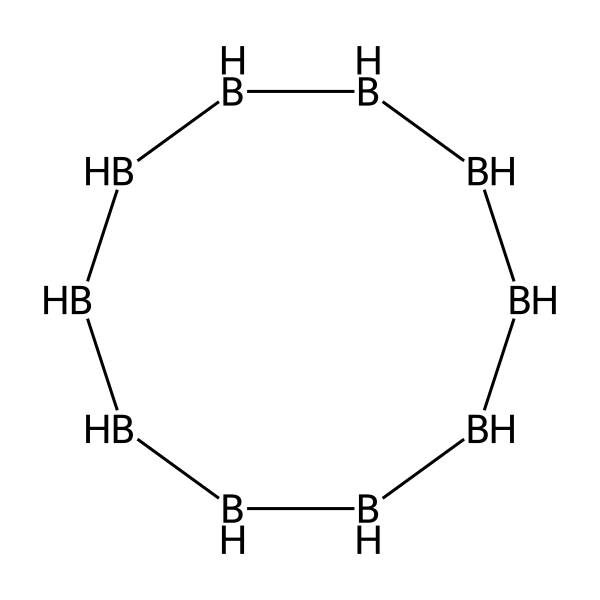How many boron atoms are in this chemical? The SMILES representation indicates several [BH] units that signify boron and hydrogen, and counting these units shows there are 10 boron atoms present in total.
Answer: 10 What is the molecular formula derived from the structure? Each boron atom has one hydrogen attached. Therefore, the formula can be written as B10H10, confirming that there are 10 boron and 10 hydrogen atoms.
Answer: B10H10 Is this compound a saturated or unsaturated borane? The structure shows that all boron atoms are surrounded by hydrogen atoms without any double or triple bonds present, indicating that the compound is saturated.
Answer: saturated What is the hybridization of the boron atoms in this structure? In boranes, boron typically exhibits sp3 hybridization due to the tetrahedral arrangement with bonds to hydrogen, therefore the hybridization of the boron atoms in this structure is sp3.
Answer: sp3 How many hydrogen atoms are bonded to each boron atom? Each boron atom in this structure is bonded to one hydrogen atom, as seen in the SMILES representation where each boron (B) is immediately followed by (H).
Answer: 1 What type of chemical bonding is primarily present in this compound? The primary type of bonding evident in this compound is covalent bonding, as it involves shared pairs of electrons between boron and hydrogen atoms.
Answer: covalent Is this borane expected to act as a neuroprotective agent based on its structure? While boranes are often studied for their properties, their neuroprotective qualities would depend on further biological evaluations beyond the structural analysis provided by the SMILES representation.
Answer: further evaluation needed 